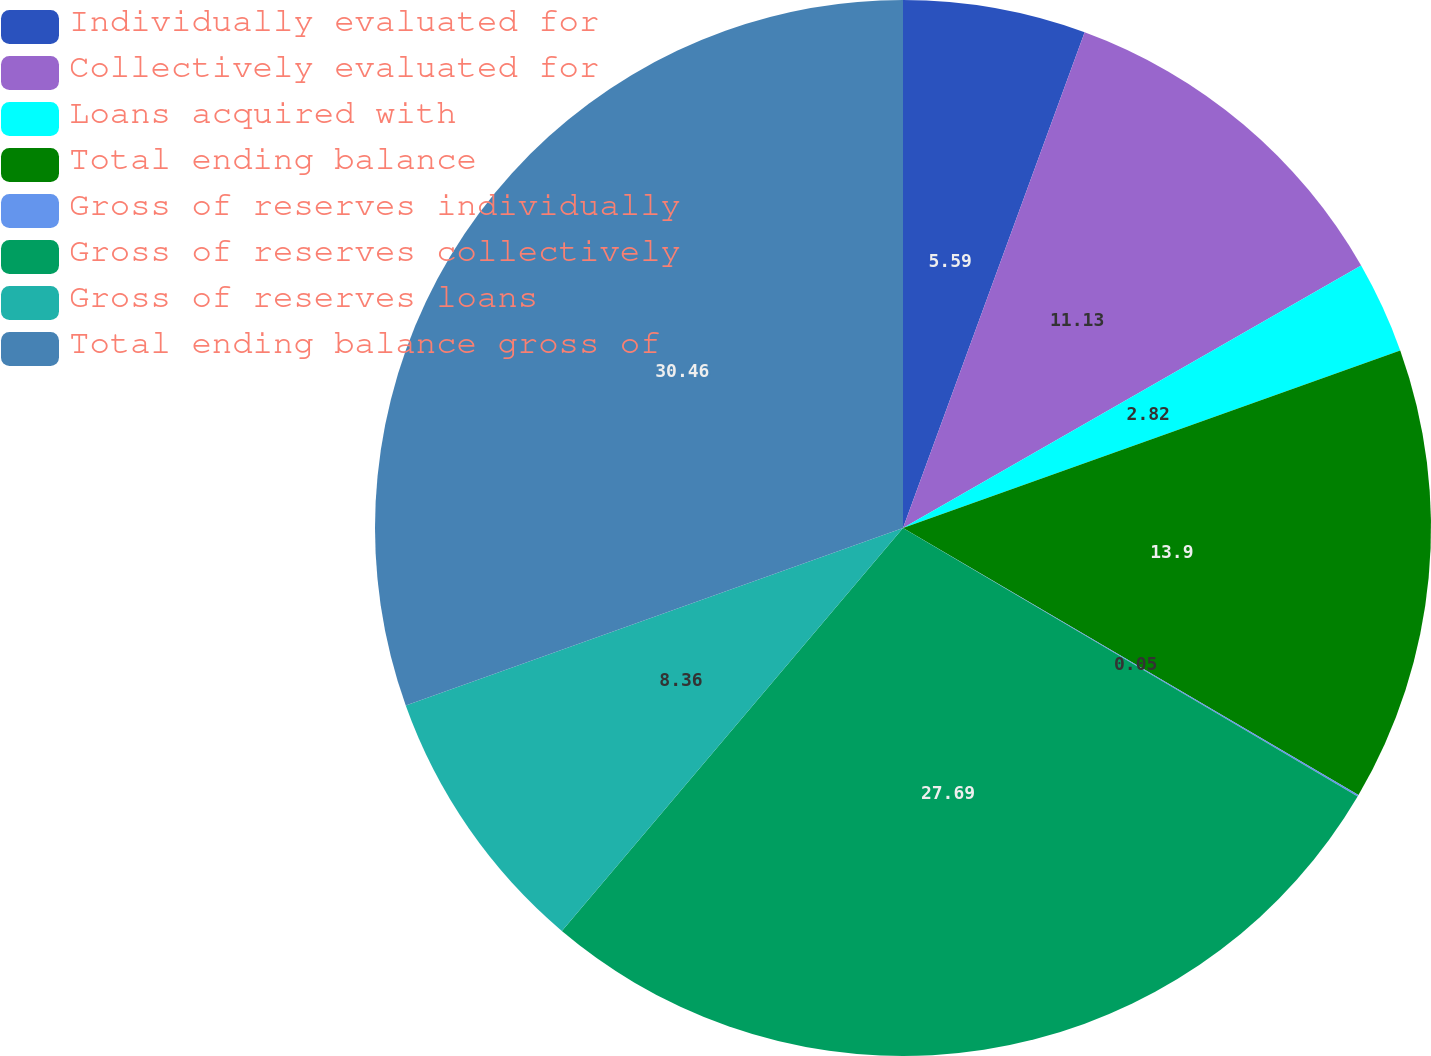Convert chart to OTSL. <chart><loc_0><loc_0><loc_500><loc_500><pie_chart><fcel>Individually evaluated for<fcel>Collectively evaluated for<fcel>Loans acquired with<fcel>Total ending balance<fcel>Gross of reserves individually<fcel>Gross of reserves collectively<fcel>Gross of reserves loans<fcel>Total ending balance gross of<nl><fcel>5.59%<fcel>11.13%<fcel>2.82%<fcel>13.9%<fcel>0.05%<fcel>27.69%<fcel>8.36%<fcel>30.46%<nl></chart> 